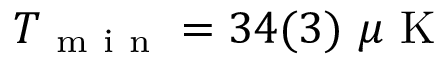<formula> <loc_0><loc_0><loc_500><loc_500>T _ { m i n } = 3 4 ( 3 ) \mu K</formula> 